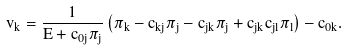Convert formula to latex. <formula><loc_0><loc_0><loc_500><loc_500>v _ { k } = \frac { 1 } { E + c _ { 0 j } \pi _ { j } } \left ( \pi _ { k } - c _ { k j } \pi _ { j } - c _ { j k } \pi _ { j } + c _ { j k } c _ { j l } \pi _ { l } \right ) - c _ { 0 k } .</formula> 